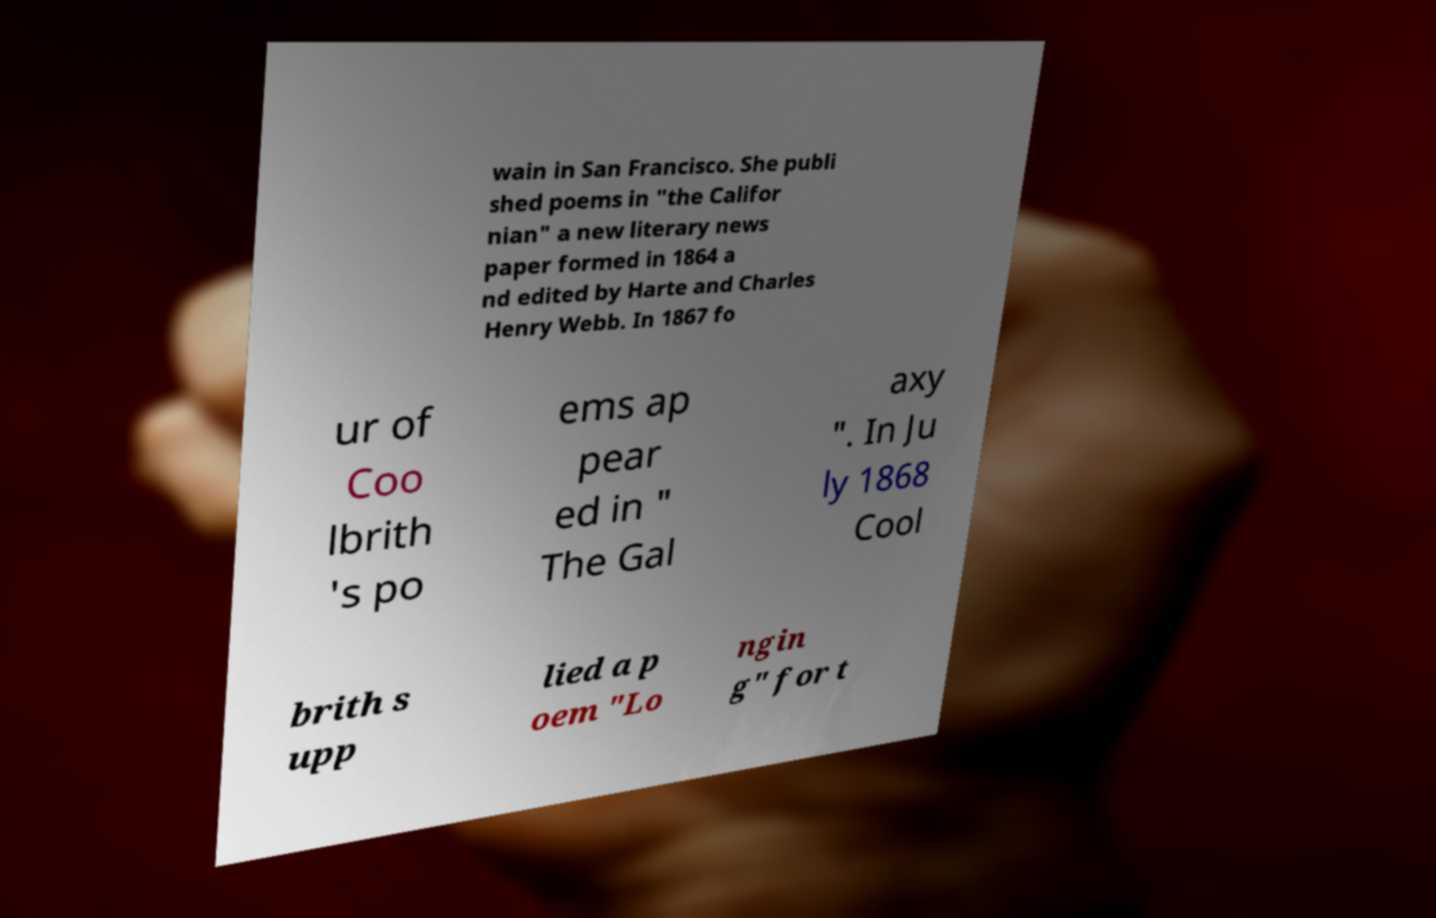What messages or text are displayed in this image? I need them in a readable, typed format. wain in San Francisco. She publi shed poems in "the Califor nian" a new literary news paper formed in 1864 a nd edited by Harte and Charles Henry Webb. In 1867 fo ur of Coo lbrith 's po ems ap pear ed in " The Gal axy ". In Ju ly 1868 Cool brith s upp lied a p oem "Lo ngin g" for t 